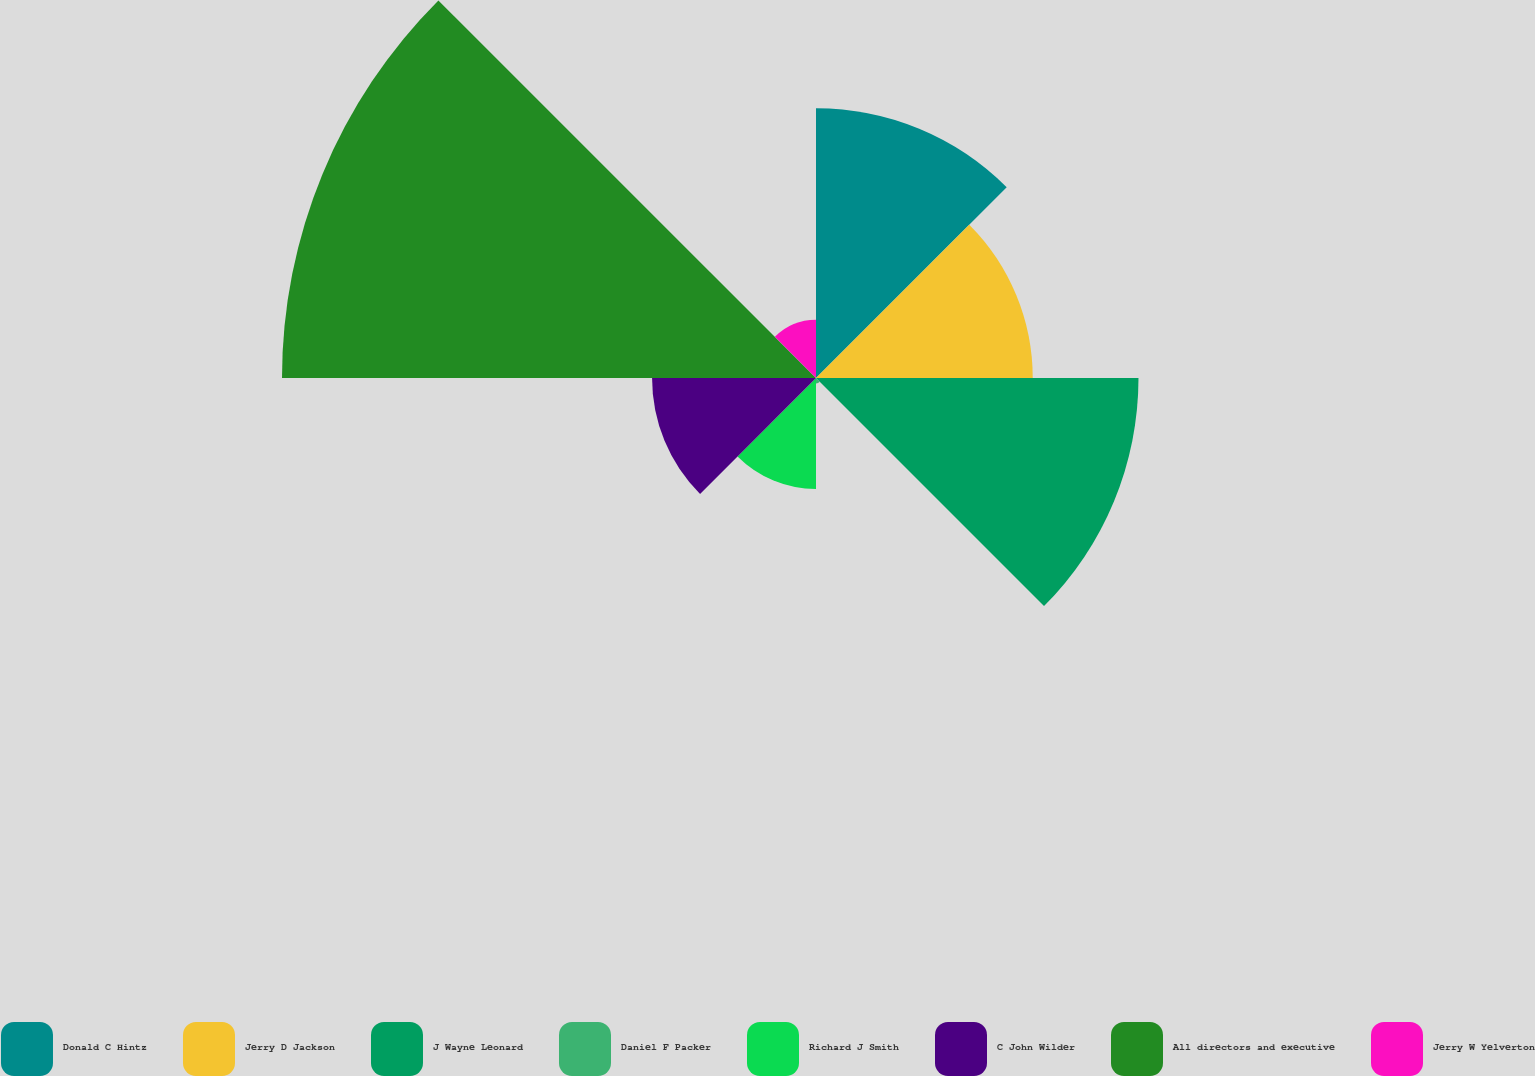Convert chart. <chart><loc_0><loc_0><loc_500><loc_500><pie_chart><fcel>Donald C Hintz<fcel>Jerry D Jackson<fcel>J Wayne Leonard<fcel>Daniel F Packer<fcel>Richard J Smith<fcel>C John Wilder<fcel>All directors and executive<fcel>Jerry W Yelverton<nl><fcel>16.04%<fcel>12.89%<fcel>19.18%<fcel>0.32%<fcel>6.6%<fcel>9.75%<fcel>31.76%<fcel>3.46%<nl></chart> 